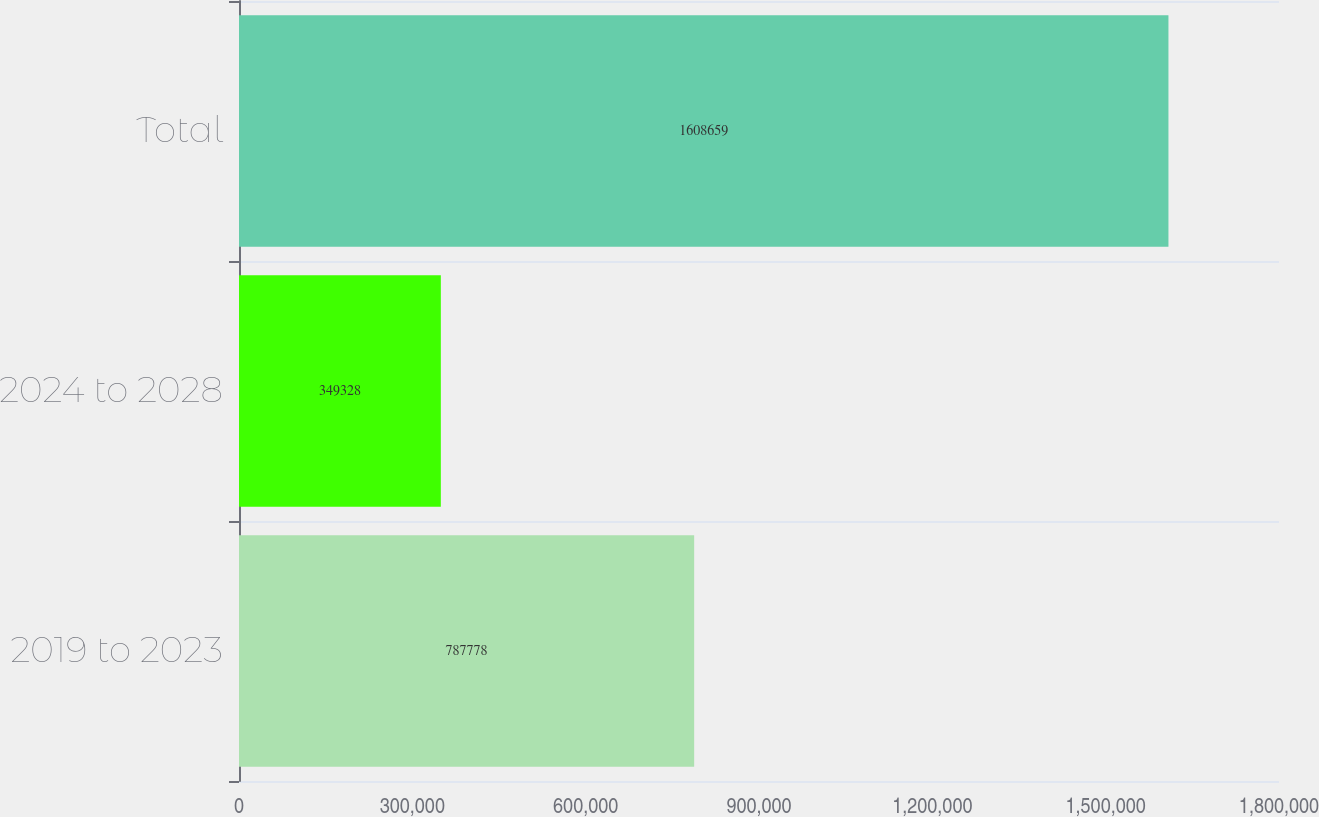Convert chart. <chart><loc_0><loc_0><loc_500><loc_500><bar_chart><fcel>2019 to 2023<fcel>2024 to 2028<fcel>Total<nl><fcel>787778<fcel>349328<fcel>1.60866e+06<nl></chart> 